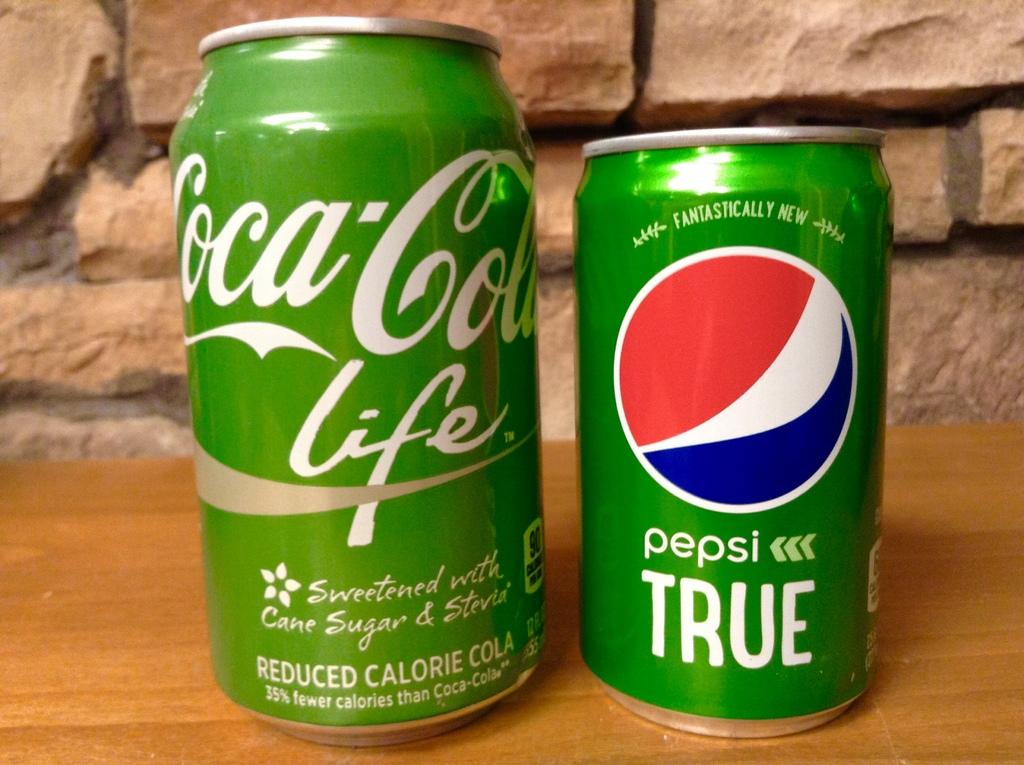<image>
Give a short and clear explanation of the subsequent image. Two green cans sit side by side, one for Cocal-Cola and the other for Pepsi. 